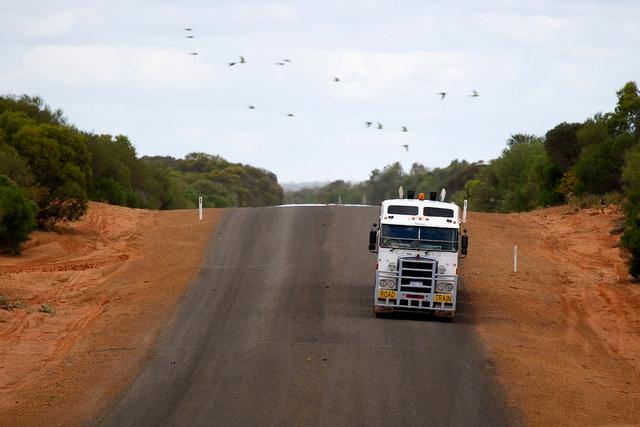Are there lines on the road?
Concise answer only. No. What is flying above the truck?
Write a very short answer. Birds. What direction is the vehicle going?
Quick response, please. Down. 